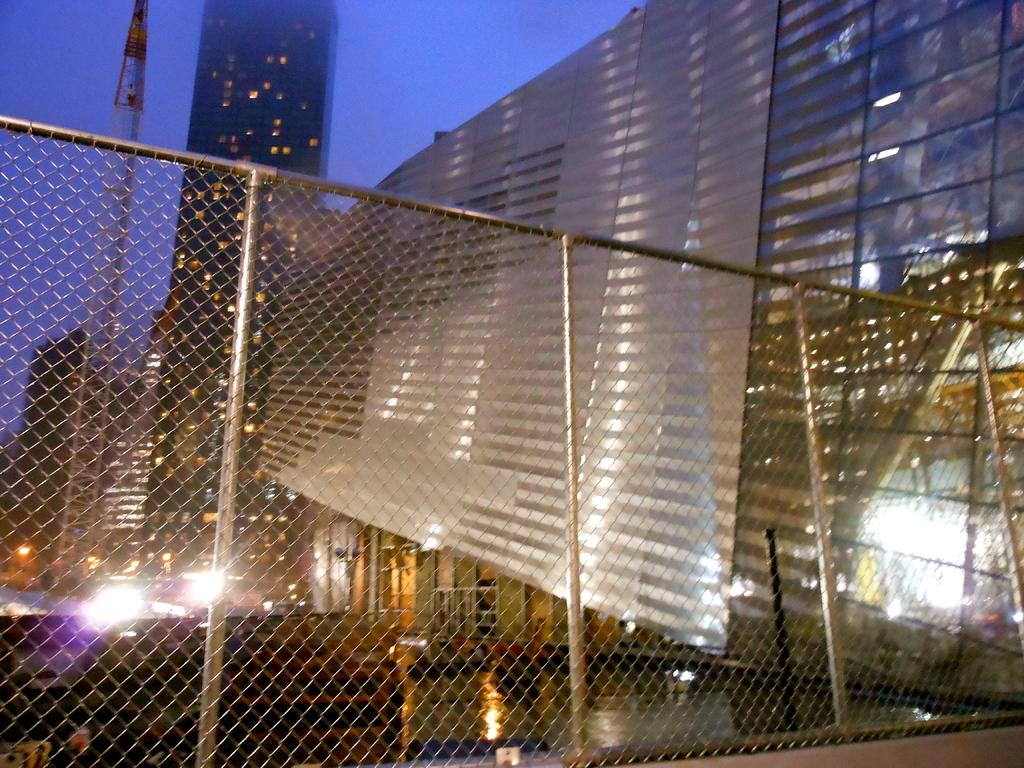What type of structure can be seen on the left side of the image? There is a tower on the left side of the image. What other structures are present in the image? There are buildings in the image. What is the purpose of the fence in the image? The purpose of the fence is not explicitly stated, but it may be used to enclose or separate areas. What can be seen on the left side of the image besides the tower? There are lights on the left side of the image. What is visible in the background of the image? The sky is visible in the background of the image. How many chickens can be seen in the image? There are no chickens present in the image. What type of sound can be heard coming from the tower in the image? The image is silent, so no sounds can be heard. 